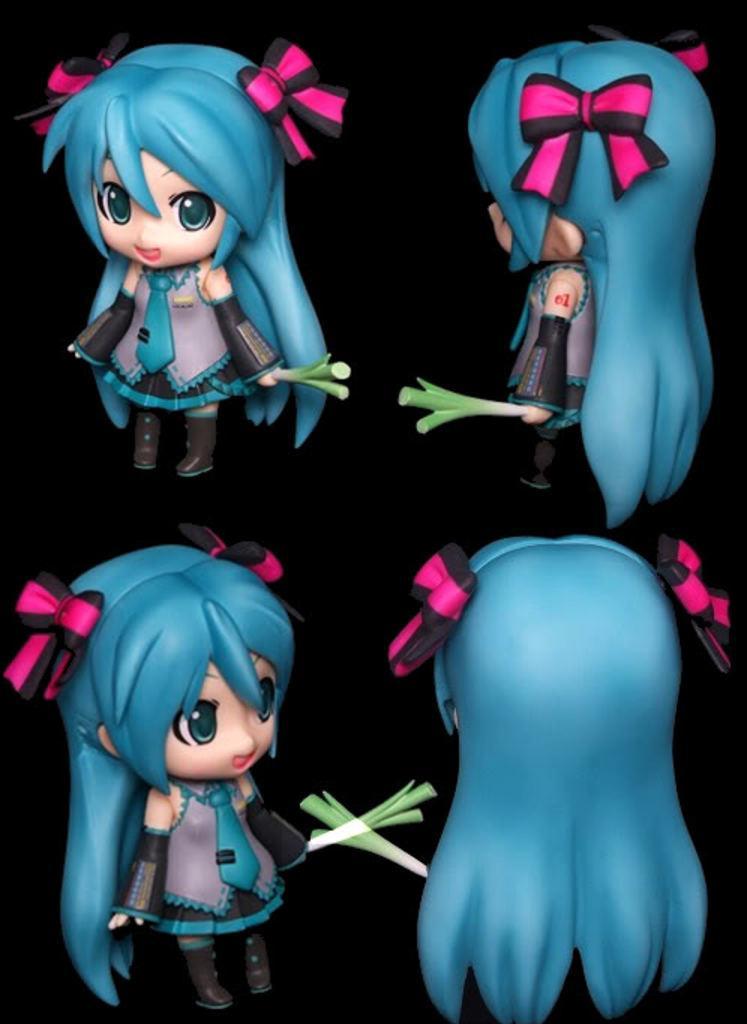Please provide a concise description of this image. In this image I can see four toys which are in black, blue and ash color dresses. These toys are holding the white and green color objects. And there is a black background. 